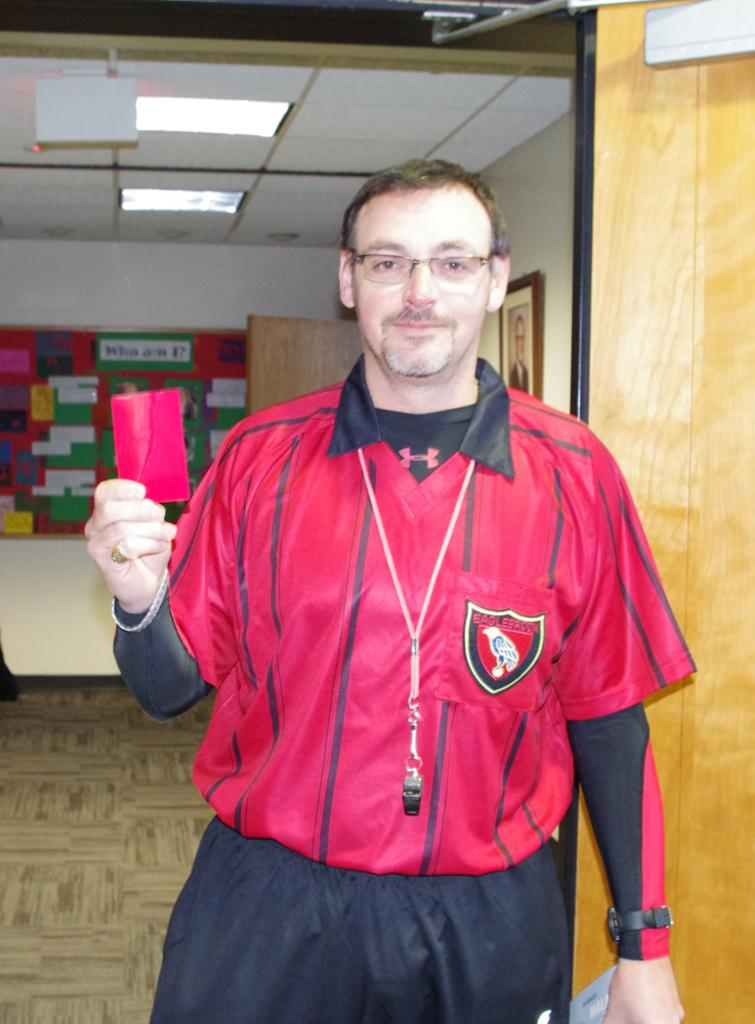What can be seen in the background of the image? There is a wall in the image. What is illuminating the scene in the image? There are lights in the image. What decorative item is present in the image? There is a photo frame in the image. Who is present in the image? There is a person in the image. What color is the jacket worn by the person in the image? The person is wearing a red color jacket. How many fingers does the person in the image have? The number of fingers the person has cannot be determined from the image, as their hands are not visible. 